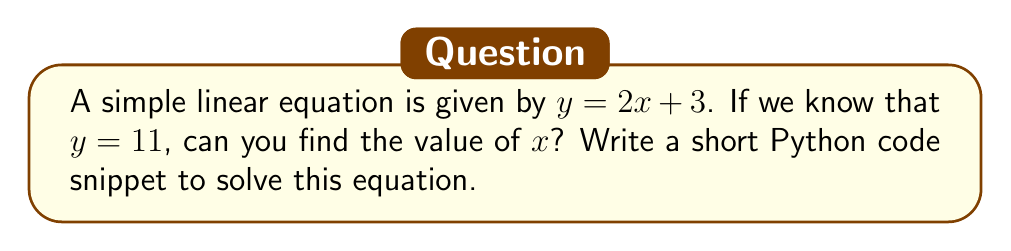Teach me how to tackle this problem. Let's break this down step-by-step:

1) We start with the equation $y = 2x + 3$

2) We know that $y = 11$, so we can substitute this:

   $11 = 2x + 3$

3) To solve for $x$, we need to isolate it. First, subtract 3 from both sides:

   $11 - 3 = 2x + 3 - 3$
   $8 = 2x$

4) Now, divide both sides by 2:

   $\frac{8}{2} = \frac{2x}{2}$
   $4 = x$

5) To solve this using Python, we can write a simple script:

   ```python
   y = 11
   x = (y - 3) / 2
   print(x)
   ```

This code does the following:
- Assigns the known value of $y$ (11) to a variable
- Solves for $x$ using the equation $x = \frac{y - 3}{2}$, which is derived from $y = 2x + 3$
- Prints the result

When you run this code, it will output 4, which is the value of $x$.
Answer: $x = 4$ 